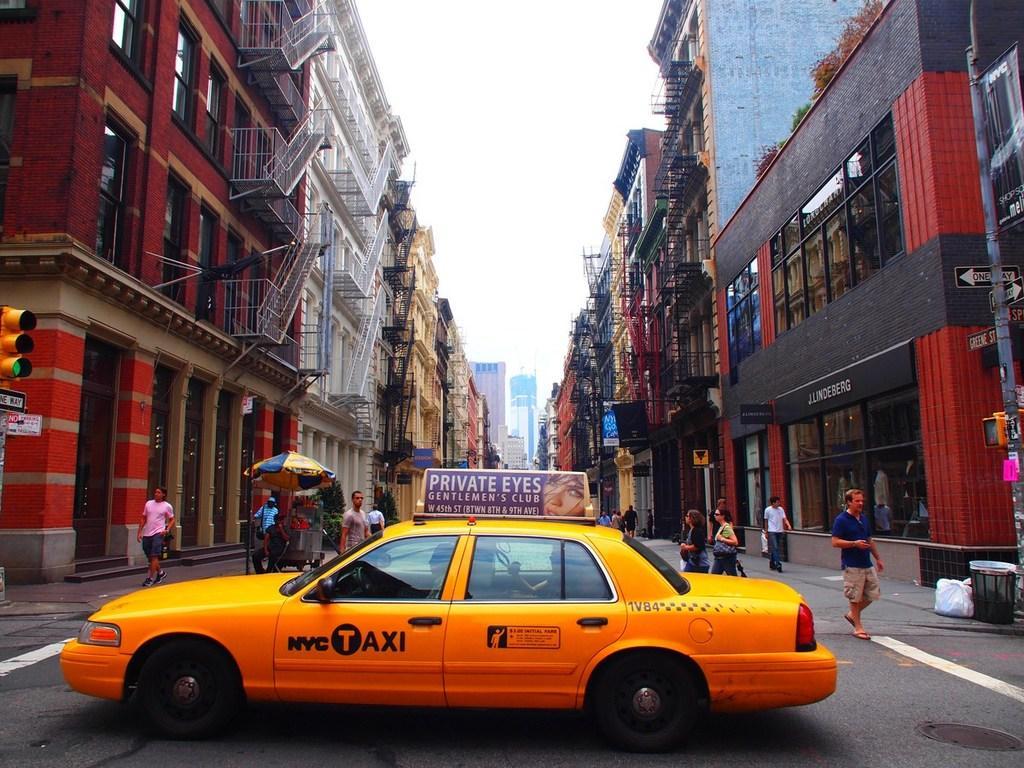How would you summarize this image in a sentence or two? In the image there is a yellow car in the middle of the road, there are many people walking in the background with buildings on either side and above its sky. 